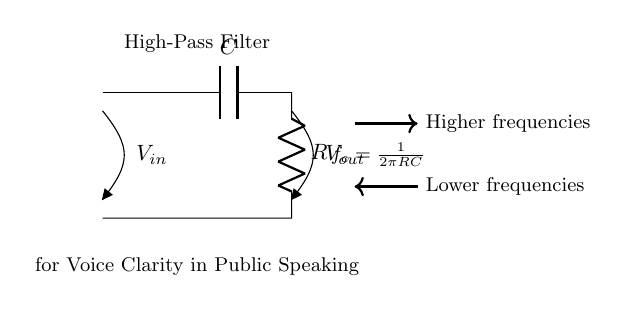What is the main function of this circuit? The main function, indicated by the circuit diagram shows a high-pass filter, which is designed to allow higher-frequency signals to pass while attenuating lower frequencies.
Answer: high-pass filter What components are present in the circuit? The circuit diagram includes a capacitor and a resistor, specifically denoted by 'C' and 'R', respectively. These components are essential for the operation of the high-pass filter.
Answer: capacitor, resistor What is the formula for the cutoff frequency? The formula for the cutoff frequency is given as f_c = 1/(2πRC), which indicates how the values of the resistor and capacitor affect the frequency at which signals are filtered.
Answer: f_c = 1/(2πRC) How does the filter affect lower frequencies? The diagram indicates that lower frequencies are attenuated, meaning that they are reduced in amplitude as they pass through the circuit, thus preventing them from reaching the output.
Answer: attenuated What is the effect of increasing the resistance on the cutoff frequency? Increasing the resistance would increase the value of RC in the formula, which increases the cutoff frequency, resulting in even lower frequencies being allowed through the circuit.
Answer: increases cutoff frequency What type of signal is this circuit primarily used for? The circuit is primarily used for enhancing voice clarity in public speaking systems, as indicated in the label on the diagram, which highlights its purpose.
Answer: voice clarity 